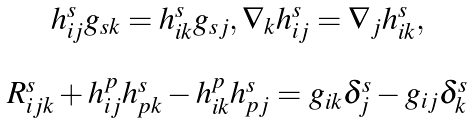Convert formula to latex. <formula><loc_0><loc_0><loc_500><loc_500>\begin{array} { c } h ^ { s } _ { i j } g _ { s k } = h ^ { s } _ { i k } g _ { s j } , \nabla _ { k } h ^ { s } _ { i j } = \nabla _ { j } h ^ { s } _ { i k } , \\ \ \\ R ^ { s } _ { i j k } + h ^ { p } _ { i j } h ^ { s } _ { p k } - h ^ { p } _ { i k } h ^ { s } _ { p j } = g _ { i k } \delta ^ { s } _ { j } - g _ { i j } \delta ^ { s } _ { k } \end{array}</formula> 